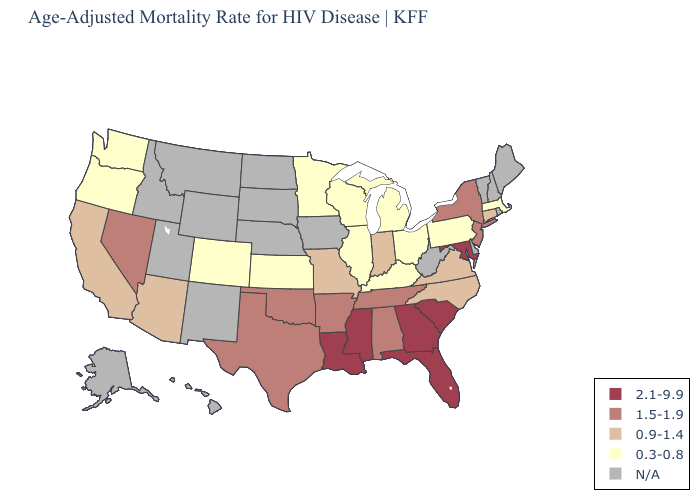Among the states that border Vermont , does New York have the lowest value?
Quick response, please. No. Among the states that border Arizona , does California have the highest value?
Keep it brief. No. Name the states that have a value in the range 1.5-1.9?
Answer briefly. Alabama, Arkansas, Nevada, New Jersey, New York, Oklahoma, Tennessee, Texas. What is the lowest value in states that border South Dakota?
Quick response, please. 0.3-0.8. Among the states that border Georgia , which have the highest value?
Quick response, please. Florida, South Carolina. What is the value of Vermont?
Concise answer only. N/A. What is the lowest value in the West?
Write a very short answer. 0.3-0.8. Name the states that have a value in the range 2.1-9.9?
Give a very brief answer. Florida, Georgia, Louisiana, Maryland, Mississippi, South Carolina. Name the states that have a value in the range 2.1-9.9?
Concise answer only. Florida, Georgia, Louisiana, Maryland, Mississippi, South Carolina. Name the states that have a value in the range 1.5-1.9?
Short answer required. Alabama, Arkansas, Nevada, New Jersey, New York, Oklahoma, Tennessee, Texas. What is the value of Oregon?
Write a very short answer. 0.3-0.8. Name the states that have a value in the range 0.9-1.4?
Keep it brief. Arizona, California, Connecticut, Indiana, Missouri, North Carolina, Virginia. Is the legend a continuous bar?
Be succinct. No. 